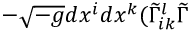Convert formula to latex. <formula><loc_0><loc_0><loc_500><loc_500>- \sqrt { - g } d x ^ { i } d x ^ { k } ( \widetilde { \Gamma } _ { i k } ^ { l } \widetilde { \Gamma }</formula> 